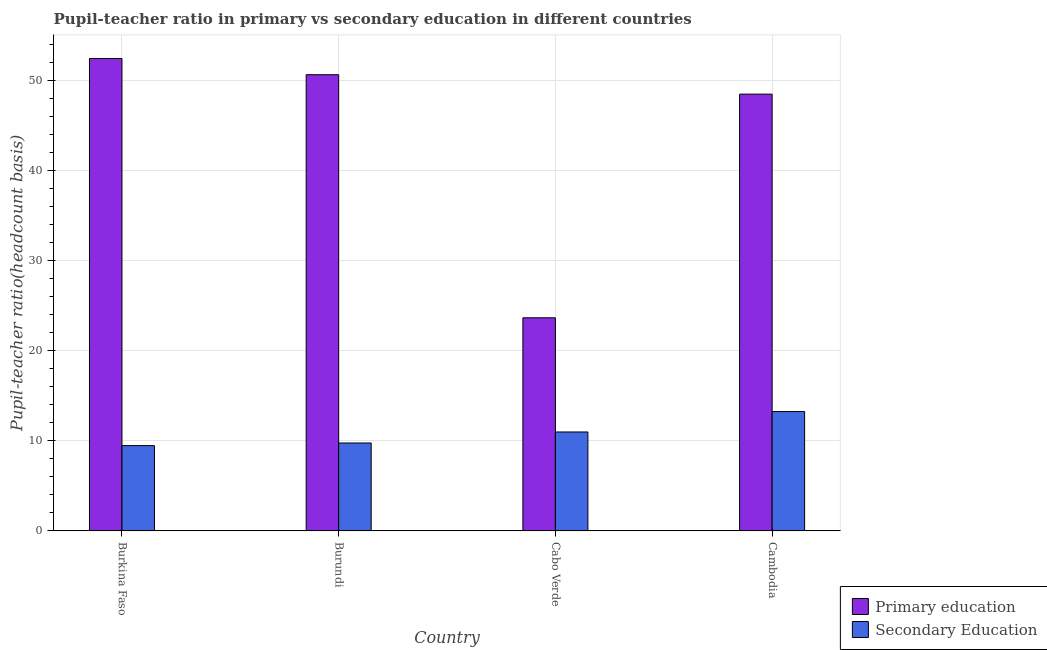How many different coloured bars are there?
Provide a short and direct response. 2. Are the number of bars on each tick of the X-axis equal?
Give a very brief answer. Yes. How many bars are there on the 2nd tick from the left?
Your answer should be compact. 2. What is the label of the 3rd group of bars from the left?
Offer a very short reply. Cabo Verde. What is the pupil teacher ratio on secondary education in Burundi?
Ensure brevity in your answer.  9.76. Across all countries, what is the maximum pupil teacher ratio on secondary education?
Your answer should be compact. 13.24. Across all countries, what is the minimum pupil teacher ratio on secondary education?
Keep it short and to the point. 9.46. In which country was the pupil-teacher ratio in primary education maximum?
Ensure brevity in your answer.  Burkina Faso. In which country was the pupil teacher ratio on secondary education minimum?
Make the answer very short. Burkina Faso. What is the total pupil-teacher ratio in primary education in the graph?
Ensure brevity in your answer.  175.09. What is the difference between the pupil-teacher ratio in primary education in Burkina Faso and that in Burundi?
Make the answer very short. 1.8. What is the difference between the pupil-teacher ratio in primary education in Burkina Faso and the pupil teacher ratio on secondary education in Burundi?
Keep it short and to the point. 42.64. What is the average pupil-teacher ratio in primary education per country?
Offer a terse response. 43.77. What is the difference between the pupil teacher ratio on secondary education and pupil-teacher ratio in primary education in Cambodia?
Make the answer very short. -35.21. In how many countries, is the pupil-teacher ratio in primary education greater than 6 ?
Your answer should be very brief. 4. What is the ratio of the pupil teacher ratio on secondary education in Burundi to that in Cambodia?
Provide a short and direct response. 0.74. Is the pupil-teacher ratio in primary education in Burkina Faso less than that in Cambodia?
Your answer should be very brief. No. What is the difference between the highest and the second highest pupil teacher ratio on secondary education?
Offer a terse response. 2.26. What is the difference between the highest and the lowest pupil-teacher ratio in primary education?
Offer a very short reply. 28.76. In how many countries, is the pupil teacher ratio on secondary education greater than the average pupil teacher ratio on secondary education taken over all countries?
Your answer should be compact. 2. Is the sum of the pupil-teacher ratio in primary education in Burkina Faso and Cambodia greater than the maximum pupil teacher ratio on secondary education across all countries?
Provide a succinct answer. Yes. What does the 1st bar from the right in Cabo Verde represents?
Provide a succinct answer. Secondary Education. How many bars are there?
Offer a very short reply. 8. Are all the bars in the graph horizontal?
Provide a short and direct response. No. Are the values on the major ticks of Y-axis written in scientific E-notation?
Provide a short and direct response. No. What is the title of the graph?
Offer a terse response. Pupil-teacher ratio in primary vs secondary education in different countries. What is the label or title of the X-axis?
Provide a short and direct response. Country. What is the label or title of the Y-axis?
Provide a short and direct response. Pupil-teacher ratio(headcount basis). What is the Pupil-teacher ratio(headcount basis) in Primary education in Burkina Faso?
Provide a succinct answer. 52.4. What is the Pupil-teacher ratio(headcount basis) in Secondary Education in Burkina Faso?
Your response must be concise. 9.46. What is the Pupil-teacher ratio(headcount basis) of Primary education in Burundi?
Your answer should be very brief. 50.6. What is the Pupil-teacher ratio(headcount basis) in Secondary Education in Burundi?
Your answer should be compact. 9.76. What is the Pupil-teacher ratio(headcount basis) in Primary education in Cabo Verde?
Provide a succinct answer. 23.64. What is the Pupil-teacher ratio(headcount basis) of Secondary Education in Cabo Verde?
Offer a very short reply. 10.98. What is the Pupil-teacher ratio(headcount basis) of Primary education in Cambodia?
Keep it short and to the point. 48.45. What is the Pupil-teacher ratio(headcount basis) of Secondary Education in Cambodia?
Offer a terse response. 13.24. Across all countries, what is the maximum Pupil-teacher ratio(headcount basis) of Primary education?
Offer a terse response. 52.4. Across all countries, what is the maximum Pupil-teacher ratio(headcount basis) in Secondary Education?
Keep it short and to the point. 13.24. Across all countries, what is the minimum Pupil-teacher ratio(headcount basis) in Primary education?
Ensure brevity in your answer.  23.64. Across all countries, what is the minimum Pupil-teacher ratio(headcount basis) in Secondary Education?
Provide a short and direct response. 9.46. What is the total Pupil-teacher ratio(headcount basis) in Primary education in the graph?
Provide a short and direct response. 175.09. What is the total Pupil-teacher ratio(headcount basis) of Secondary Education in the graph?
Keep it short and to the point. 43.44. What is the difference between the Pupil-teacher ratio(headcount basis) of Primary education in Burkina Faso and that in Burundi?
Provide a succinct answer. 1.8. What is the difference between the Pupil-teacher ratio(headcount basis) in Secondary Education in Burkina Faso and that in Burundi?
Offer a terse response. -0.29. What is the difference between the Pupil-teacher ratio(headcount basis) in Primary education in Burkina Faso and that in Cabo Verde?
Your answer should be very brief. 28.76. What is the difference between the Pupil-teacher ratio(headcount basis) in Secondary Education in Burkina Faso and that in Cabo Verde?
Offer a very short reply. -1.51. What is the difference between the Pupil-teacher ratio(headcount basis) of Primary education in Burkina Faso and that in Cambodia?
Provide a short and direct response. 3.95. What is the difference between the Pupil-teacher ratio(headcount basis) of Secondary Education in Burkina Faso and that in Cambodia?
Provide a short and direct response. -3.78. What is the difference between the Pupil-teacher ratio(headcount basis) of Primary education in Burundi and that in Cabo Verde?
Keep it short and to the point. 26.96. What is the difference between the Pupil-teacher ratio(headcount basis) of Secondary Education in Burundi and that in Cabo Verde?
Offer a terse response. -1.22. What is the difference between the Pupil-teacher ratio(headcount basis) in Primary education in Burundi and that in Cambodia?
Your answer should be compact. 2.15. What is the difference between the Pupil-teacher ratio(headcount basis) in Secondary Education in Burundi and that in Cambodia?
Keep it short and to the point. -3.49. What is the difference between the Pupil-teacher ratio(headcount basis) in Primary education in Cabo Verde and that in Cambodia?
Provide a short and direct response. -24.81. What is the difference between the Pupil-teacher ratio(headcount basis) in Secondary Education in Cabo Verde and that in Cambodia?
Your answer should be very brief. -2.26. What is the difference between the Pupil-teacher ratio(headcount basis) of Primary education in Burkina Faso and the Pupil-teacher ratio(headcount basis) of Secondary Education in Burundi?
Give a very brief answer. 42.64. What is the difference between the Pupil-teacher ratio(headcount basis) of Primary education in Burkina Faso and the Pupil-teacher ratio(headcount basis) of Secondary Education in Cabo Verde?
Ensure brevity in your answer.  41.42. What is the difference between the Pupil-teacher ratio(headcount basis) in Primary education in Burkina Faso and the Pupil-teacher ratio(headcount basis) in Secondary Education in Cambodia?
Provide a succinct answer. 39.16. What is the difference between the Pupil-teacher ratio(headcount basis) of Primary education in Burundi and the Pupil-teacher ratio(headcount basis) of Secondary Education in Cabo Verde?
Make the answer very short. 39.63. What is the difference between the Pupil-teacher ratio(headcount basis) in Primary education in Burundi and the Pupil-teacher ratio(headcount basis) in Secondary Education in Cambodia?
Your response must be concise. 37.36. What is the difference between the Pupil-teacher ratio(headcount basis) in Primary education in Cabo Verde and the Pupil-teacher ratio(headcount basis) in Secondary Education in Cambodia?
Offer a terse response. 10.4. What is the average Pupil-teacher ratio(headcount basis) in Primary education per country?
Your answer should be very brief. 43.77. What is the average Pupil-teacher ratio(headcount basis) in Secondary Education per country?
Your answer should be very brief. 10.86. What is the difference between the Pupil-teacher ratio(headcount basis) in Primary education and Pupil-teacher ratio(headcount basis) in Secondary Education in Burkina Faso?
Your answer should be compact. 42.94. What is the difference between the Pupil-teacher ratio(headcount basis) in Primary education and Pupil-teacher ratio(headcount basis) in Secondary Education in Burundi?
Make the answer very short. 40.85. What is the difference between the Pupil-teacher ratio(headcount basis) of Primary education and Pupil-teacher ratio(headcount basis) of Secondary Education in Cabo Verde?
Provide a short and direct response. 12.66. What is the difference between the Pupil-teacher ratio(headcount basis) of Primary education and Pupil-teacher ratio(headcount basis) of Secondary Education in Cambodia?
Keep it short and to the point. 35.21. What is the ratio of the Pupil-teacher ratio(headcount basis) of Primary education in Burkina Faso to that in Burundi?
Your answer should be compact. 1.04. What is the ratio of the Pupil-teacher ratio(headcount basis) in Secondary Education in Burkina Faso to that in Burundi?
Your answer should be compact. 0.97. What is the ratio of the Pupil-teacher ratio(headcount basis) in Primary education in Burkina Faso to that in Cabo Verde?
Provide a short and direct response. 2.22. What is the ratio of the Pupil-teacher ratio(headcount basis) in Secondary Education in Burkina Faso to that in Cabo Verde?
Keep it short and to the point. 0.86. What is the ratio of the Pupil-teacher ratio(headcount basis) in Primary education in Burkina Faso to that in Cambodia?
Your answer should be very brief. 1.08. What is the ratio of the Pupil-teacher ratio(headcount basis) in Secondary Education in Burkina Faso to that in Cambodia?
Give a very brief answer. 0.71. What is the ratio of the Pupil-teacher ratio(headcount basis) in Primary education in Burundi to that in Cabo Verde?
Offer a terse response. 2.14. What is the ratio of the Pupil-teacher ratio(headcount basis) in Secondary Education in Burundi to that in Cabo Verde?
Offer a terse response. 0.89. What is the ratio of the Pupil-teacher ratio(headcount basis) in Primary education in Burundi to that in Cambodia?
Your answer should be compact. 1.04. What is the ratio of the Pupil-teacher ratio(headcount basis) in Secondary Education in Burundi to that in Cambodia?
Provide a short and direct response. 0.74. What is the ratio of the Pupil-teacher ratio(headcount basis) of Primary education in Cabo Verde to that in Cambodia?
Your answer should be very brief. 0.49. What is the ratio of the Pupil-teacher ratio(headcount basis) in Secondary Education in Cabo Verde to that in Cambodia?
Your answer should be very brief. 0.83. What is the difference between the highest and the second highest Pupil-teacher ratio(headcount basis) in Primary education?
Provide a succinct answer. 1.8. What is the difference between the highest and the second highest Pupil-teacher ratio(headcount basis) of Secondary Education?
Keep it short and to the point. 2.26. What is the difference between the highest and the lowest Pupil-teacher ratio(headcount basis) in Primary education?
Your answer should be very brief. 28.76. What is the difference between the highest and the lowest Pupil-teacher ratio(headcount basis) of Secondary Education?
Offer a terse response. 3.78. 